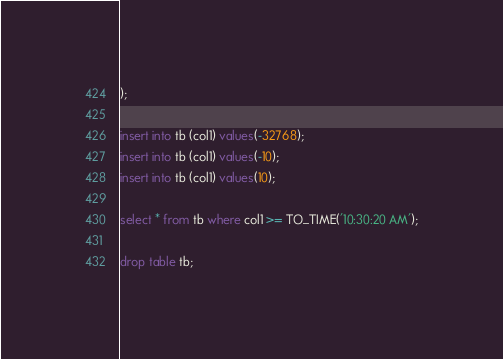Convert code to text. <code><loc_0><loc_0><loc_500><loc_500><_SQL_>);

insert into tb (col1) values(-32768);
insert into tb (col1) values(-10);
insert into tb (col1) values(10);

select * from tb where col1 >= TO_TIME('10:30:20 AM');

drop table tb;

</code> 